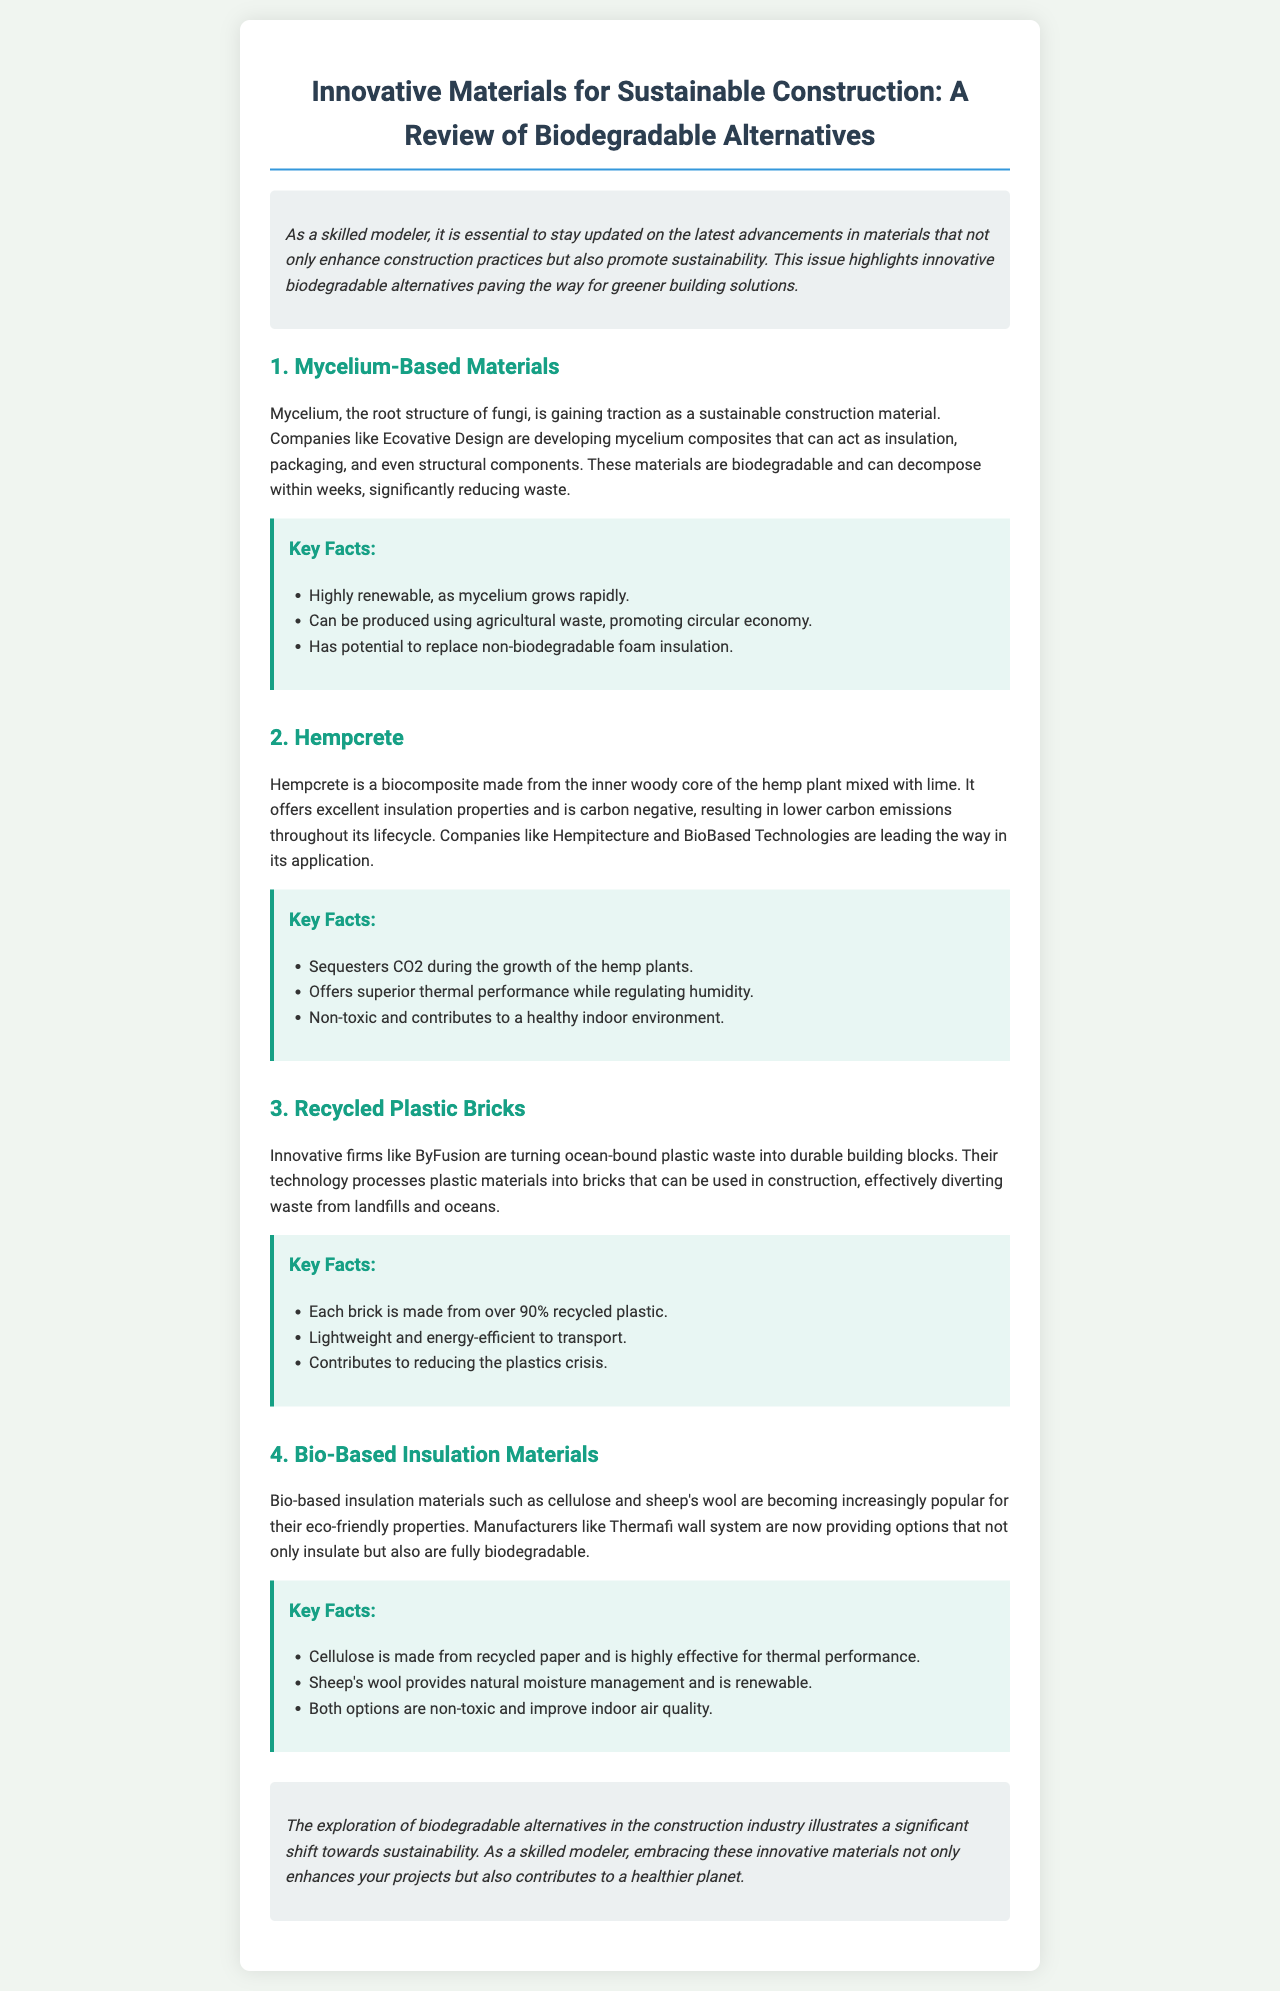what is mycelium? Mycelium is the root structure of fungi that is gaining traction as a sustainable construction material.
Answer: root structure of fungi who is developing mycelium composites? Companies like Ecovative Design are mentioned as developers of mycelium composites.
Answer: Ecovative Design what is Hempcrete made from? Hempcrete is made from the inner woody core of the hemp plant mixed with lime.
Answer: hemp plant mixed with lime what is the carbon impact of Hempcrete? Hempcrete is carbon negative, resulting in lower carbon emissions throughout its lifecycle.
Answer: carbon negative what percentage of recycled plastic is in each recycled plastic brick? Each recycled plastic brick is made from over 90% recycled plastic.
Answer: over 90% which insulation material is made from recycled paper? Cellulose is made from recycled paper and is highly effective for thermal performance.
Answer: Cellulose what type of companies are leading in hempcrete application? Companies like Hempitecture and BioBased Technologies are leading in the application of hempcrete.
Answer: Hempitecture and BioBased Technologies how do biodegradable alternatives benefit the construction industry? Biodegradable alternatives illustrate a significant shift towards sustainability in the construction industry.
Answer: shift towards sustainability what type of materials does the newsletter focus on? The newsletter focuses on innovative biodegradable alternatives for sustainable construction.
Answer: biodegradable alternatives 